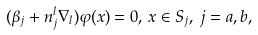<formula> <loc_0><loc_0><loc_500><loc_500>( \beta _ { j } + n _ { j } ^ { l } \nabla _ { l } ) \varphi ( x ) = 0 , \, x \in S _ { j } , \, j = a , b ,</formula> 